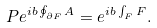Convert formula to latex. <formula><loc_0><loc_0><loc_500><loc_500>P e ^ { i b \oint _ { \partial F } A } = e ^ { i b \int _ { F } F } .</formula> 